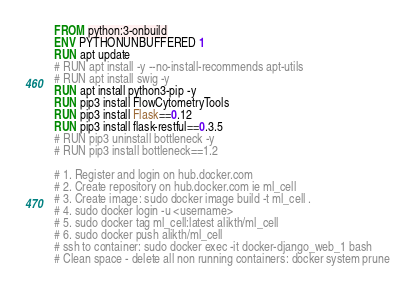Convert code to text. <code><loc_0><loc_0><loc_500><loc_500><_Dockerfile_>FROM python:3-onbuild
ENV PYTHONUNBUFFERED 1
RUN apt update
# RUN apt install -y --no-install-recommends apt-utils
# RUN apt install swig -y
RUN apt install python3-pip -y
RUN pip3 install FlowCytometryTools
RUN pip3 install Flask==0.12
RUN pip3 install flask-restful==0.3.5
# RUN pip3 uninstall bottleneck -y
# RUN pip3 install bottleneck==1.2

# 1. Register and login on hub.docker.com
# 2. Create repository on hub.docker.com ie ml_cell
# 3. Create image: sudo docker image build -t ml_cell .
# 4. sudo docker login -u <username>
# 5. sudo docker tag ml_cell:latest alikth/ml_cell
# 6. sudo docker push alikth/ml_cell
# ssh to container: sudo docker exec -it docker-django_web_1 bash
# Clean space - delete all non running containers: docker system prune
</code> 